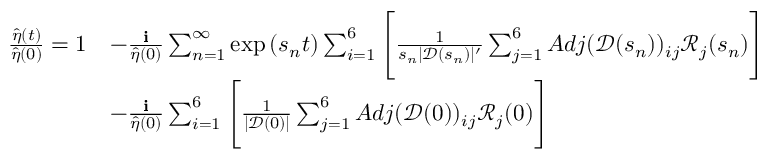<formula> <loc_0><loc_0><loc_500><loc_500>\begin{array} { r l } { \frac { \hat { \eta } ( t ) } { \hat { \eta } ( 0 ) } = 1 } & { - \frac { i } { \hat { \eta } ( 0 ) } \sum _ { n = 1 } ^ { \infty } \exp { ( s _ { n } t ) } \sum _ { i = 1 } ^ { 6 } \left [ \frac { 1 } { s _ { n } | \ m a t h s c r { D } ( s _ { n } ) | ^ { \prime } } \sum _ { j = 1 } ^ { 6 } A d j ( \ m a t h s c r { D } ( s _ { n } ) ) _ { i j } \ m a t h s c r { R } _ { j } ( s _ { n } ) \right ] } \\ & { - \frac { i } { \hat { \eta } ( 0 ) } \sum _ { i = 1 } ^ { 6 } \left [ \frac { 1 } { | \ m a t h s c r { D } ( 0 ) | } \sum _ { j = 1 } ^ { 6 } A d j ( \ m a t h s c r { D } ( 0 ) ) _ { i j } \ m a t h s c r { R } _ { j } ( 0 ) \right ] } \end{array}</formula> 